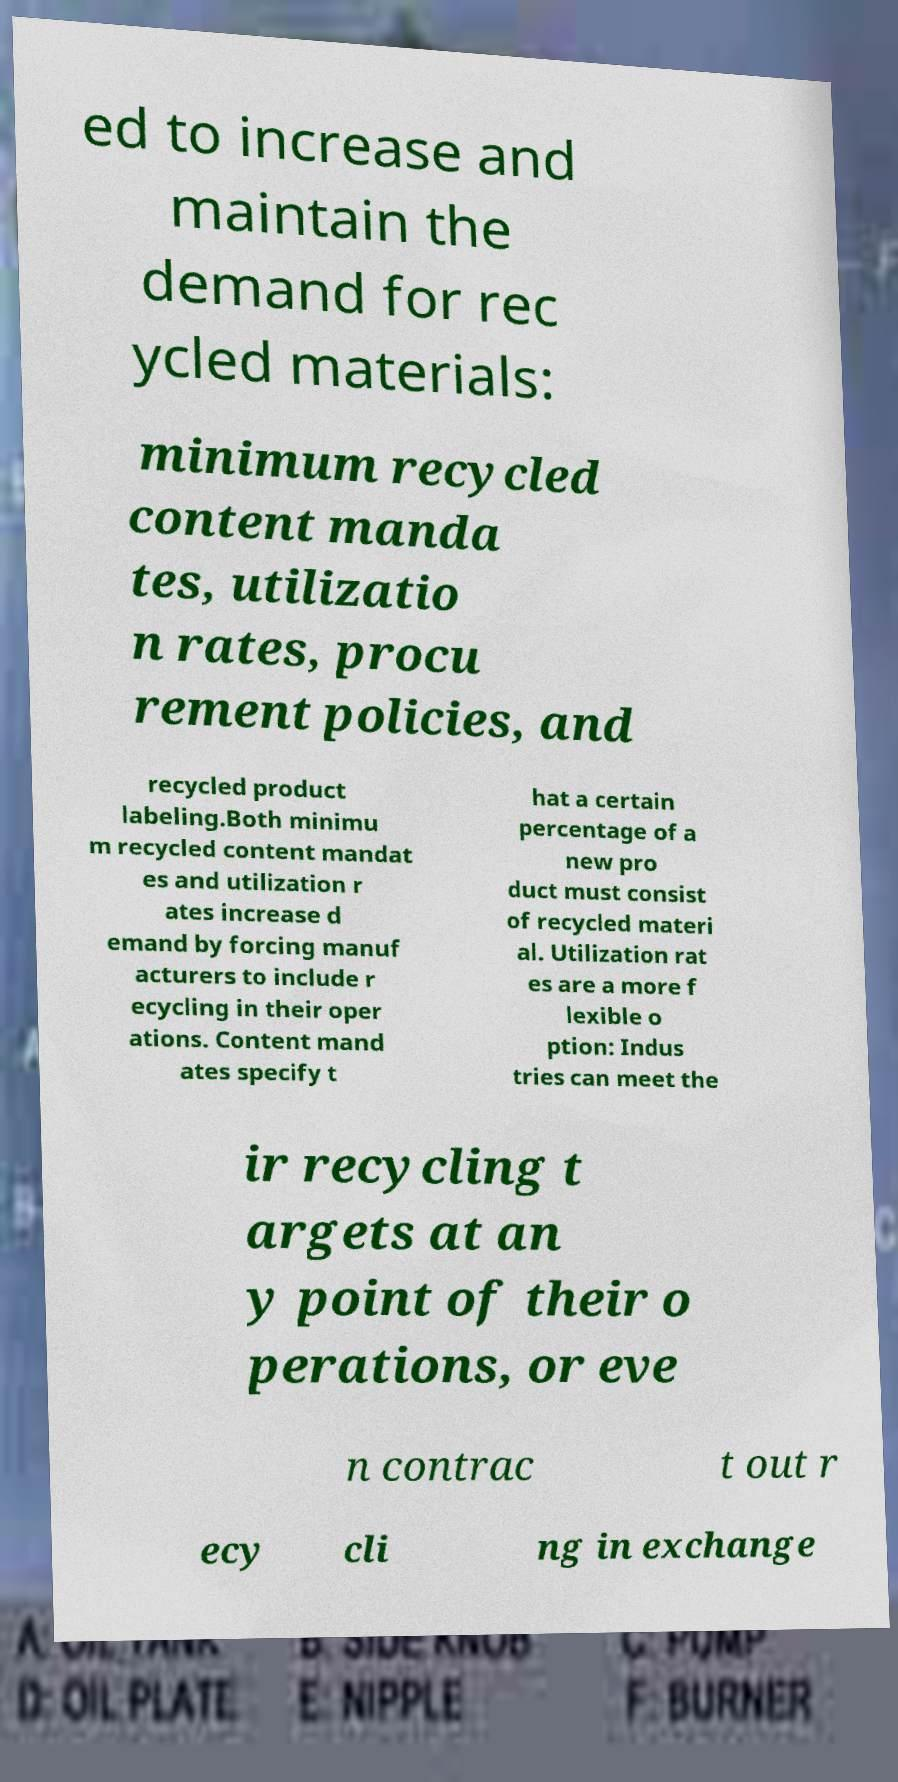Could you extract and type out the text from this image? ed to increase and maintain the demand for rec ycled materials: minimum recycled content manda tes, utilizatio n rates, procu rement policies, and recycled product labeling.Both minimu m recycled content mandat es and utilization r ates increase d emand by forcing manuf acturers to include r ecycling in their oper ations. Content mand ates specify t hat a certain percentage of a new pro duct must consist of recycled materi al. Utilization rat es are a more f lexible o ption: Indus tries can meet the ir recycling t argets at an y point of their o perations, or eve n contrac t out r ecy cli ng in exchange 